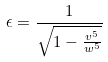<formula> <loc_0><loc_0><loc_500><loc_500>\epsilon = \frac { 1 } { \sqrt { 1 - \frac { v ^ { 5 } } { w ^ { 5 } } } }</formula> 